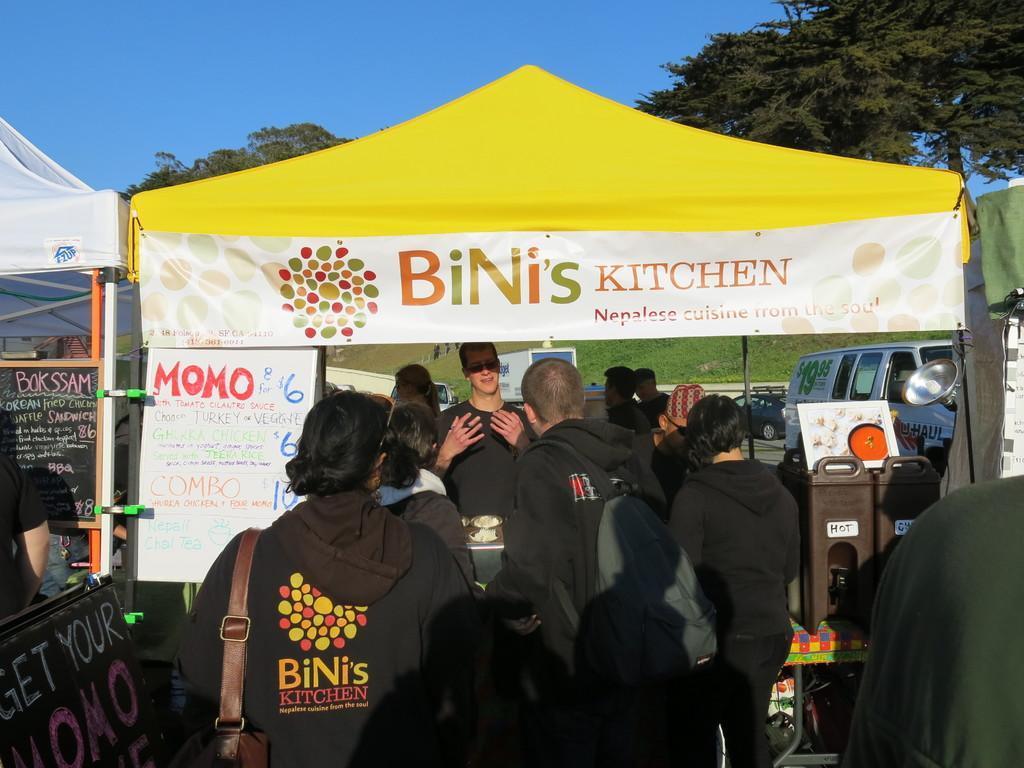In one or two sentences, can you explain what this image depicts? Here people are standing, there are tents and cars, these are trees and a sky. 